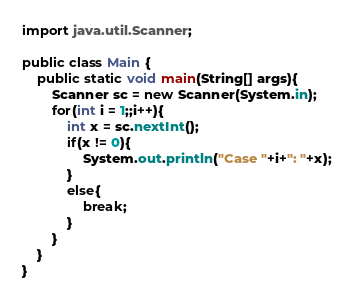<code> <loc_0><loc_0><loc_500><loc_500><_Java_>import java.util.Scanner;

public class Main {
    public static void main(String[] args){
        Scanner sc = new Scanner(System.in);
        for(int i = 1;;i++){
            int x = sc.nextInt();
            if(x != 0){
                System.out.println("Case "+i+": "+x);
            }
            else{
                break;
            }
        }
    }
}
</code> 